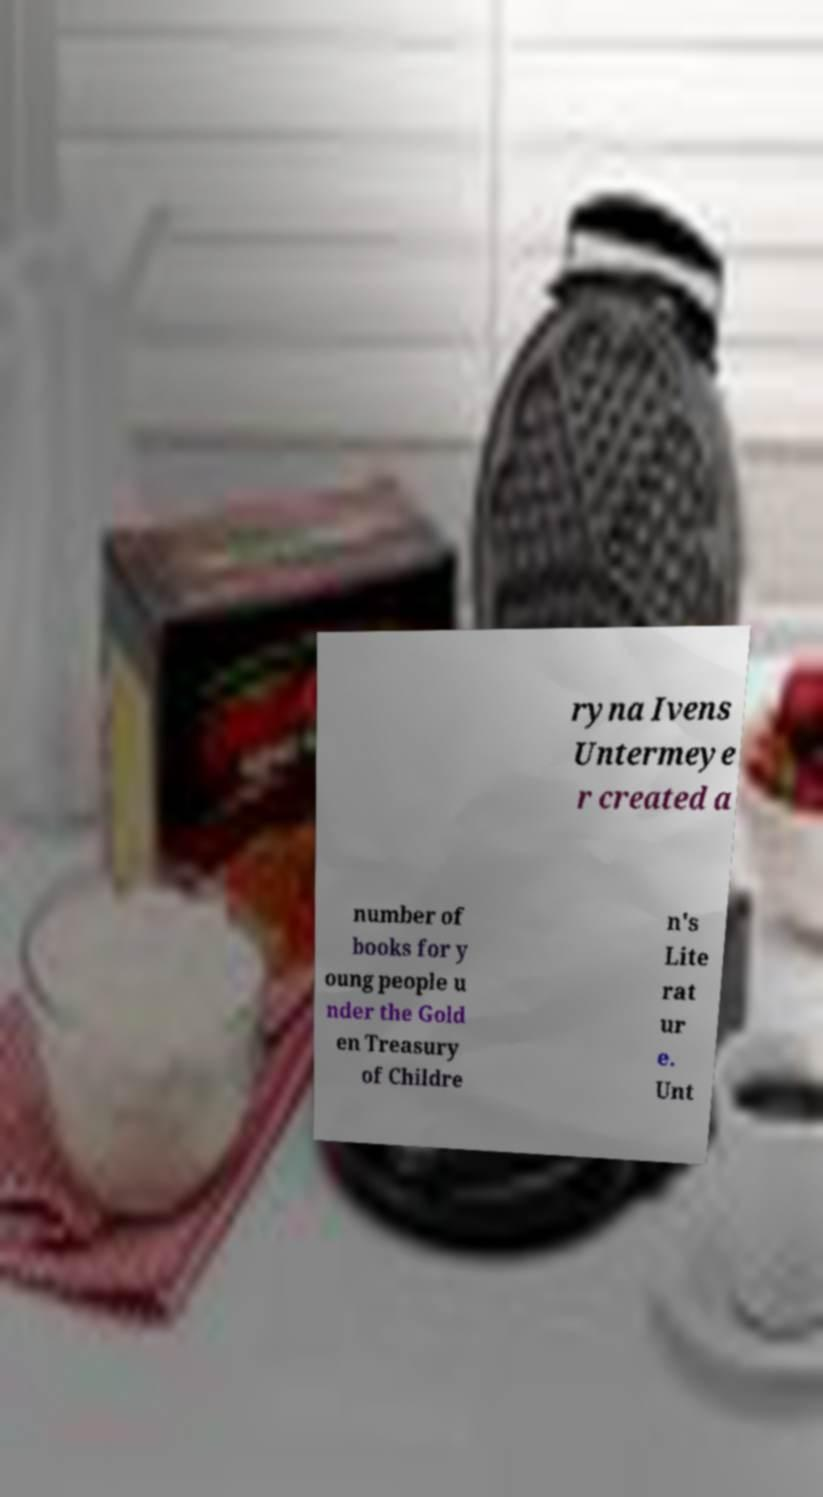For documentation purposes, I need the text within this image transcribed. Could you provide that? ryna Ivens Untermeye r created a number of books for y oung people u nder the Gold en Treasury of Childre n's Lite rat ur e. Unt 